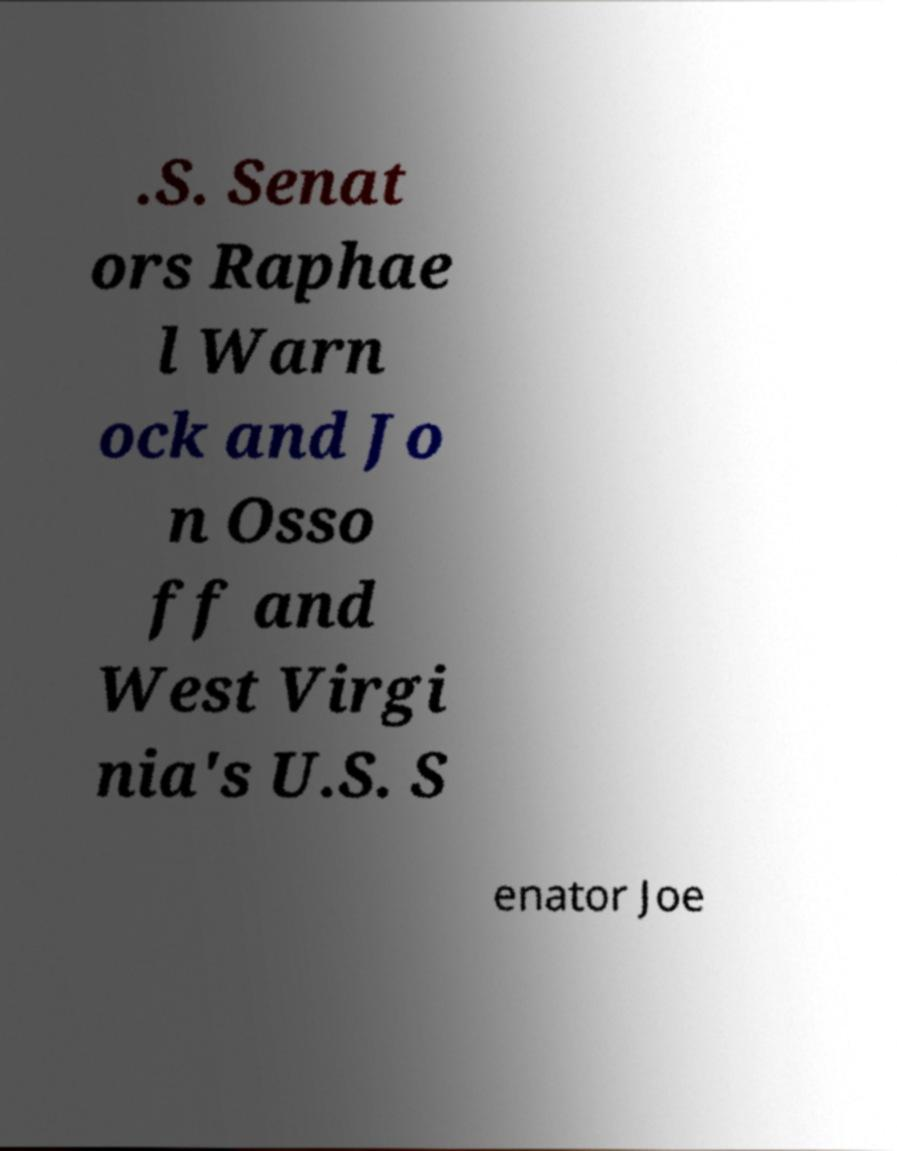Please read and relay the text visible in this image. What does it say? .S. Senat ors Raphae l Warn ock and Jo n Osso ff and West Virgi nia's U.S. S enator Joe 